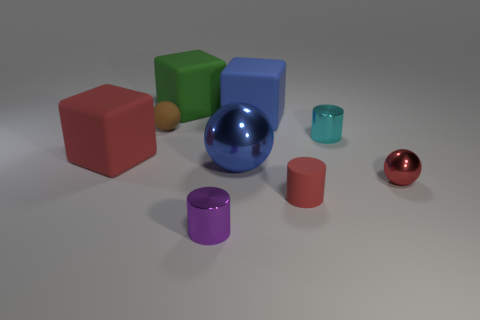There is a cube that is the same color as the large metallic sphere; what material is it?
Your response must be concise. Rubber. How many things are large matte objects that are behind the brown ball or blue things?
Your response must be concise. 3. Do the rubber thing that is in front of the blue shiny thing and the small purple object have the same size?
Keep it short and to the point. Yes. Is the number of blue matte objects on the right side of the cyan cylinder less than the number of blue cubes?
Your answer should be very brief. Yes. What is the material of the brown sphere that is the same size as the matte cylinder?
Offer a terse response. Rubber. What number of small objects are either metallic spheres or red cubes?
Keep it short and to the point. 1. What number of objects are either red cubes in front of the large green matte cube or red objects right of the small purple metallic cylinder?
Keep it short and to the point. 3. Are there fewer big green cubes than big objects?
Provide a short and direct response. Yes. What shape is the brown rubber thing that is the same size as the rubber cylinder?
Keep it short and to the point. Sphere. How many other things are the same color as the tiny metallic sphere?
Offer a terse response. 2. 